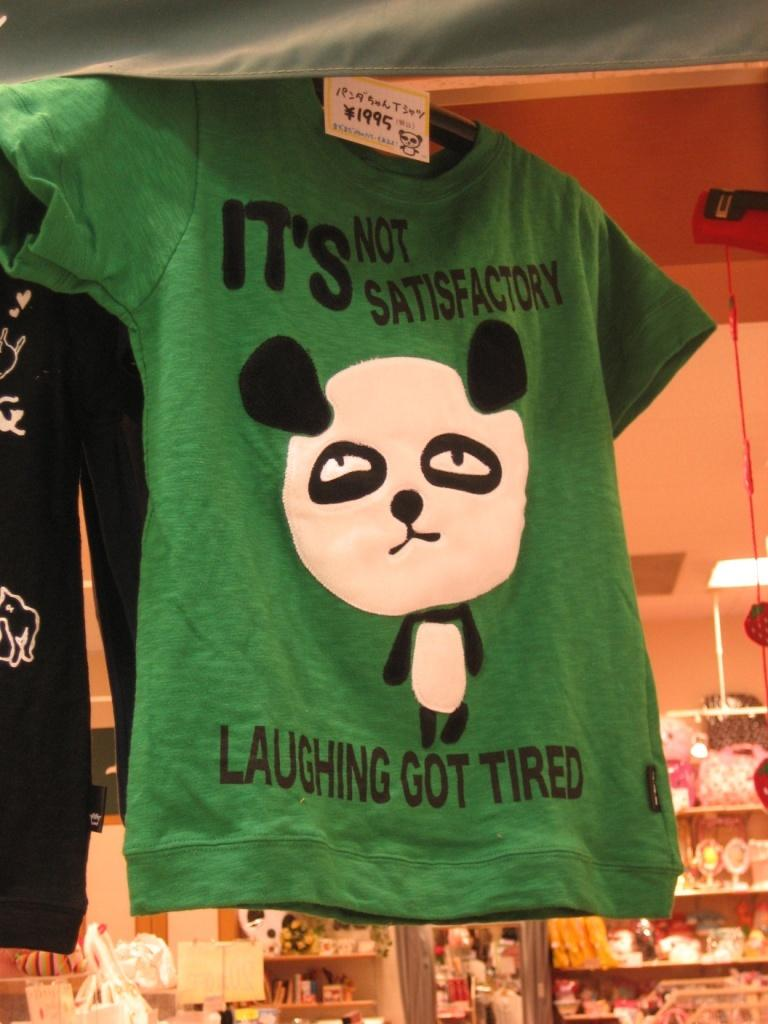What type of clothing items are present in the image? There are t-shirts in the image. What can be seen on the shelves in the image? There are objects on shelves in the image. What is the background of the image? There is a wall visible in the image. What type of glove is being used to paint on the canvas in the image? There is no glove or canvas present in the image; it only features t-shirts and objects on shelves. 